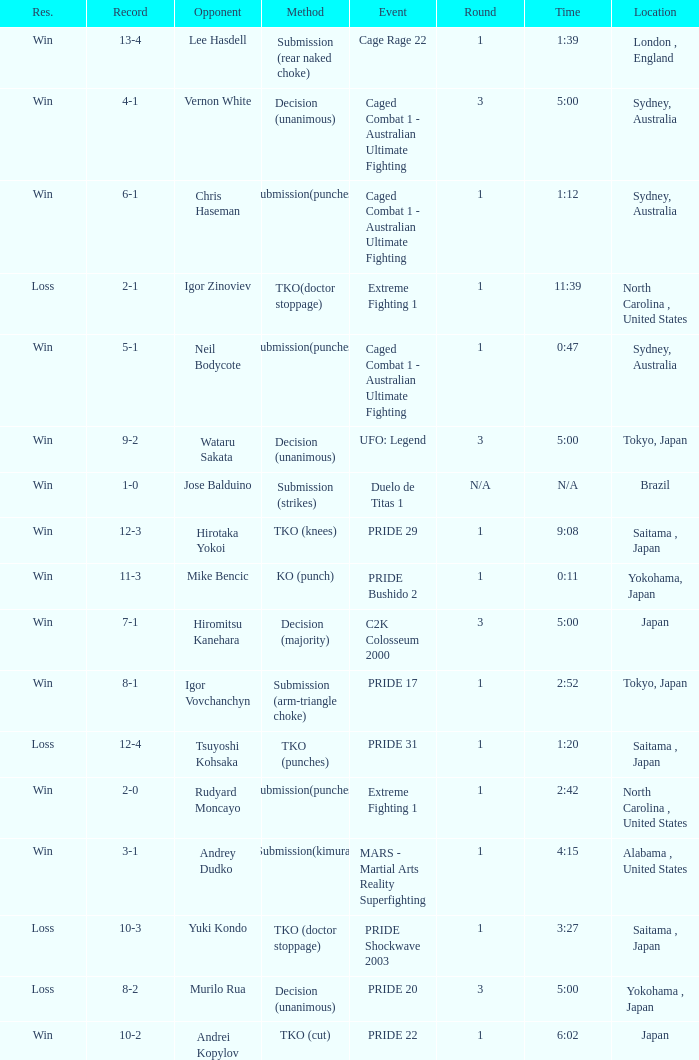Which Res has a Method of decision (unanimous) and an Opponent of Wataru Sakata? Win. 